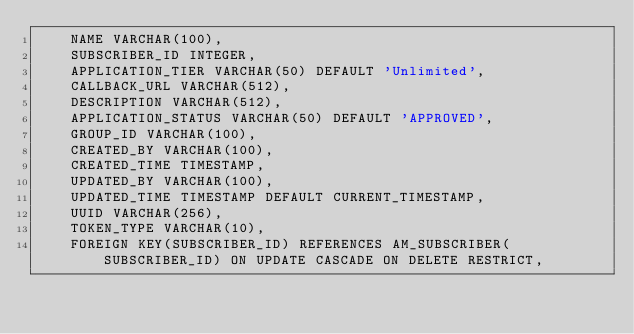Convert code to text. <code><loc_0><loc_0><loc_500><loc_500><_SQL_>    NAME VARCHAR(100),
    SUBSCRIBER_ID INTEGER,
    APPLICATION_TIER VARCHAR(50) DEFAULT 'Unlimited',
    CALLBACK_URL VARCHAR(512),
    DESCRIPTION VARCHAR(512),
    APPLICATION_STATUS VARCHAR(50) DEFAULT 'APPROVED',
    GROUP_ID VARCHAR(100),
    CREATED_BY VARCHAR(100),
    CREATED_TIME TIMESTAMP,
    UPDATED_BY VARCHAR(100),
    UPDATED_TIME TIMESTAMP DEFAULT CURRENT_TIMESTAMP,
    UUID VARCHAR(256),
    TOKEN_TYPE VARCHAR(10),
    FOREIGN KEY(SUBSCRIBER_ID) REFERENCES AM_SUBSCRIBER(SUBSCRIBER_ID) ON UPDATE CASCADE ON DELETE RESTRICT,</code> 